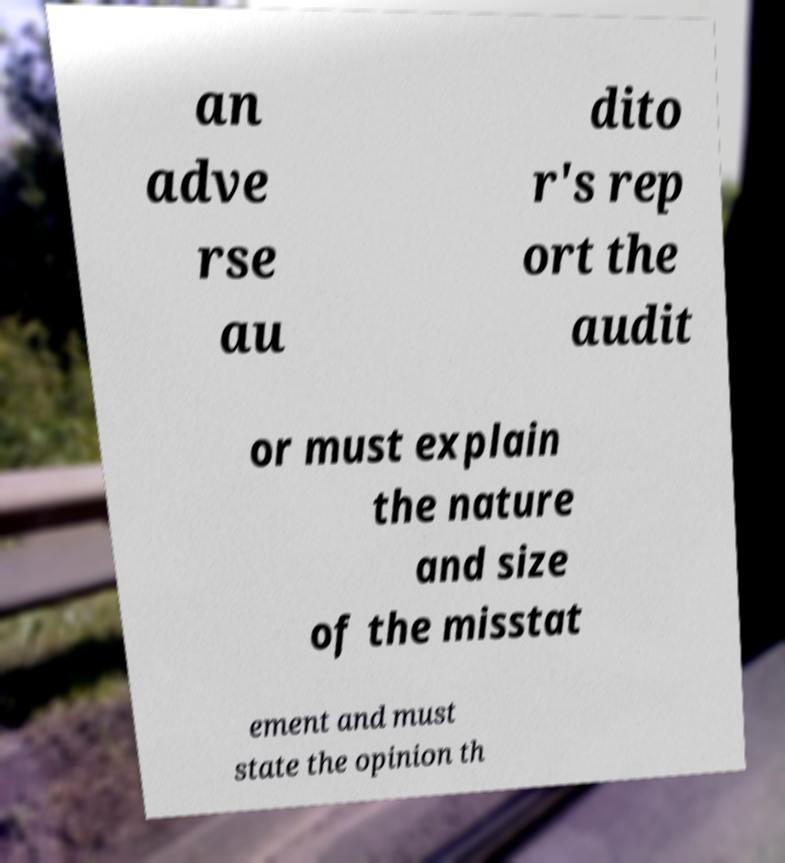I need the written content from this picture converted into text. Can you do that? an adve rse au dito r's rep ort the audit or must explain the nature and size of the misstat ement and must state the opinion th 